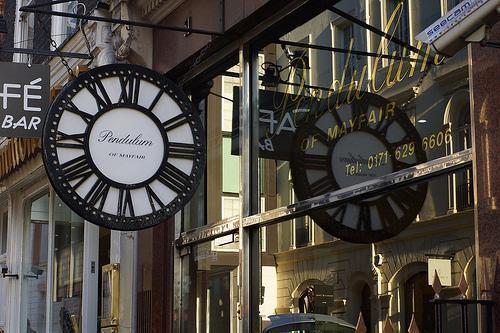How many people are pictured here?
Give a very brief answer. 0. How many signs are in this picture?
Give a very brief answer. 2. 